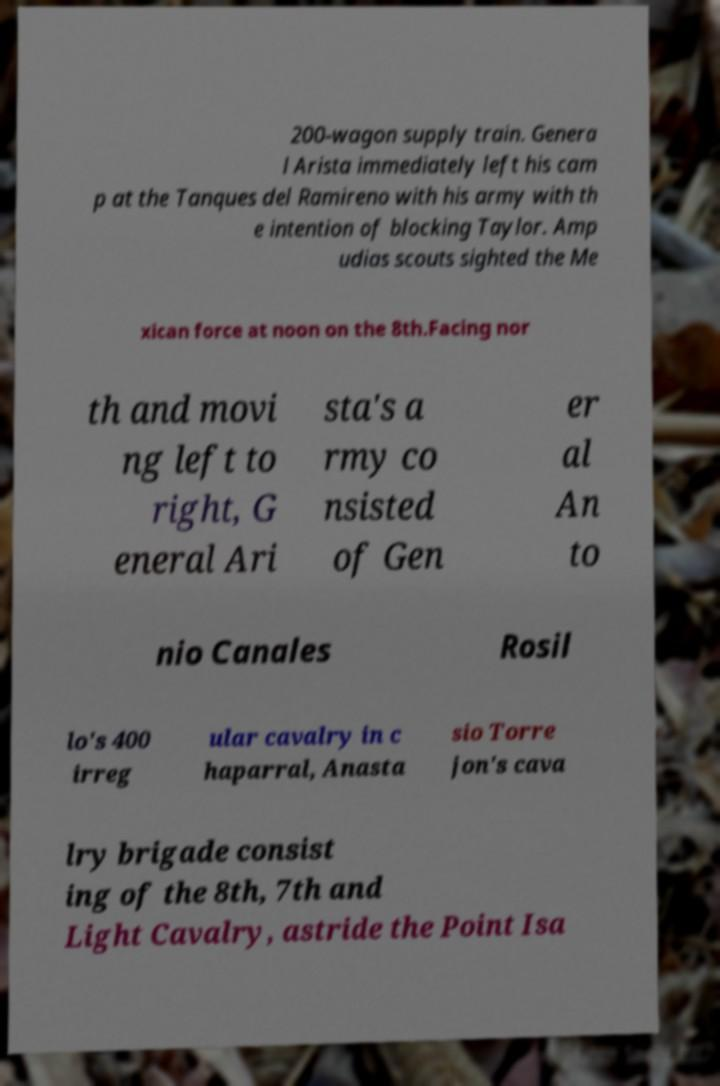What messages or text are displayed in this image? I need them in a readable, typed format. 200-wagon supply train. Genera l Arista immediately left his cam p at the Tanques del Ramireno with his army with th e intention of blocking Taylor. Amp udias scouts sighted the Me xican force at noon on the 8th.Facing nor th and movi ng left to right, G eneral Ari sta's a rmy co nsisted of Gen er al An to nio Canales Rosil lo's 400 irreg ular cavalry in c haparral, Anasta sio Torre jon's cava lry brigade consist ing of the 8th, 7th and Light Cavalry, astride the Point Isa 